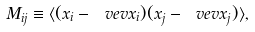<formula> <loc_0><loc_0><loc_500><loc_500>M _ { i j } \equiv \langle ( x _ { i } - \ v e v { x _ { i } } ) ( x _ { j } - \ v e v { x _ { j } } ) \rangle ,</formula> 